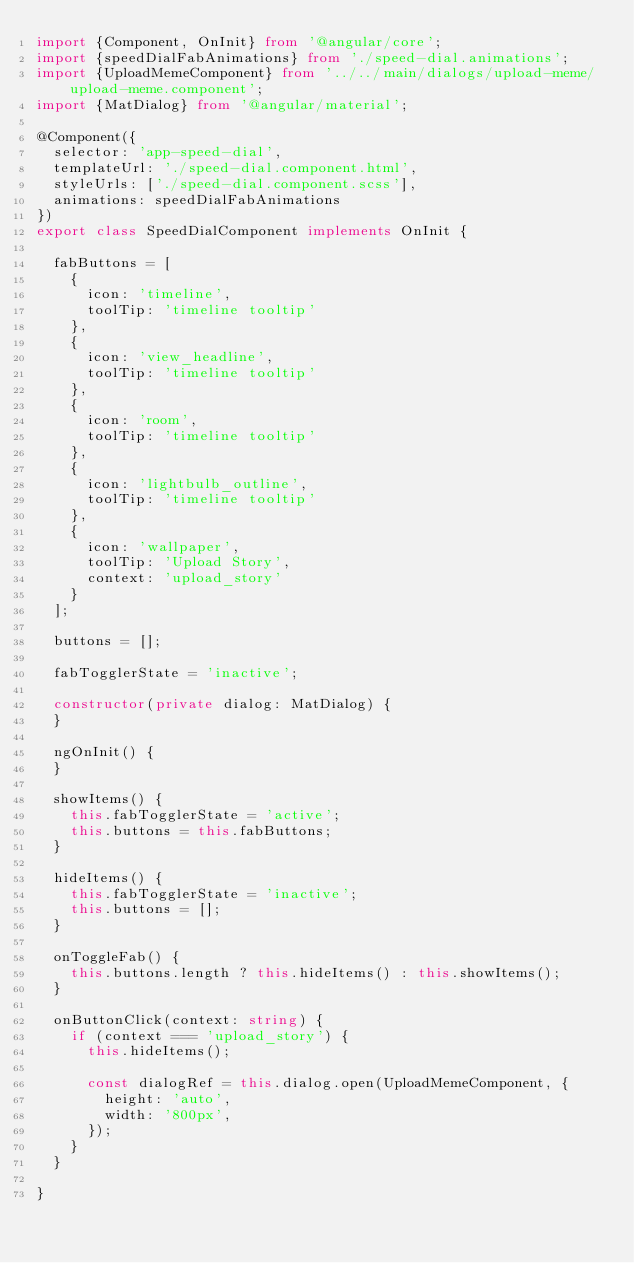<code> <loc_0><loc_0><loc_500><loc_500><_TypeScript_>import {Component, OnInit} from '@angular/core';
import {speedDialFabAnimations} from './speed-dial.animations';
import {UploadMemeComponent} from '../../main/dialogs/upload-meme/upload-meme.component';
import {MatDialog} from '@angular/material';

@Component({
  selector: 'app-speed-dial',
  templateUrl: './speed-dial.component.html',
  styleUrls: ['./speed-dial.component.scss'],
  animations: speedDialFabAnimations
})
export class SpeedDialComponent implements OnInit {

  fabButtons = [
    {
      icon: 'timeline',
      toolTip: 'timeline tooltip'
    },
    {
      icon: 'view_headline',
      toolTip: 'timeline tooltip'
    },
    {
      icon: 'room',
      toolTip: 'timeline tooltip'
    },
    {
      icon: 'lightbulb_outline',
      toolTip: 'timeline tooltip'
    },
    {
      icon: 'wallpaper',
      toolTip: 'Upload Story',
      context: 'upload_story'
    }
  ];

  buttons = [];

  fabTogglerState = 'inactive';

  constructor(private dialog: MatDialog) {
  }

  ngOnInit() {
  }

  showItems() {
    this.fabTogglerState = 'active';
    this.buttons = this.fabButtons;
  }

  hideItems() {
    this.fabTogglerState = 'inactive';
    this.buttons = [];
  }

  onToggleFab() {
    this.buttons.length ? this.hideItems() : this.showItems();
  }

  onButtonClick(context: string) {
    if (context === 'upload_story') {
      this.hideItems();

      const dialogRef = this.dialog.open(UploadMemeComponent, {
        height: 'auto',
        width: '800px',
      });
    }
  }

}
</code> 